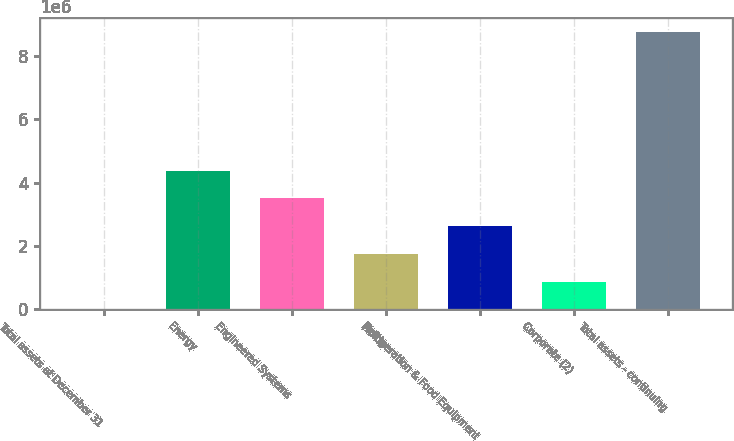Convert chart to OTSL. <chart><loc_0><loc_0><loc_500><loc_500><bar_chart><fcel>Total assets at December 31<fcel>Energy<fcel>Engineered Systems<fcel>Fluids<fcel>Refrigeration & Food Equipment<fcel>Corporate (2)<fcel>Total assets - continuing<nl><fcel>2014<fcel>4.38261e+06<fcel>3.50649e+06<fcel>1.75425e+06<fcel>2.63037e+06<fcel>878134<fcel>8.76321e+06<nl></chart> 